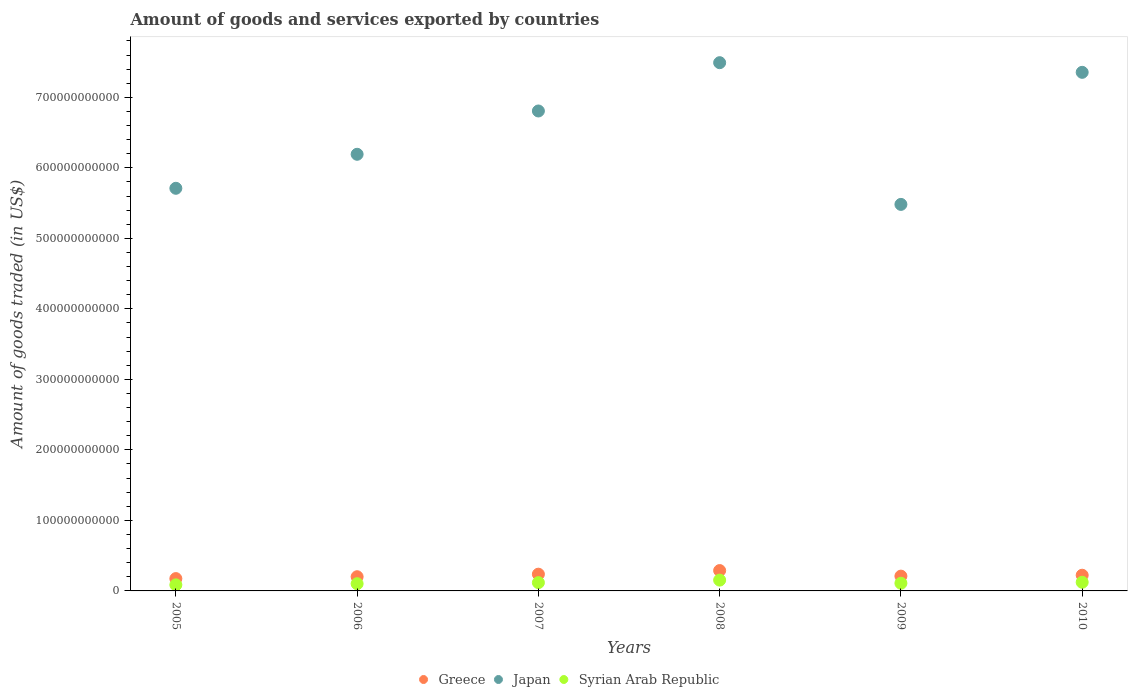How many different coloured dotlines are there?
Make the answer very short. 3. What is the total amount of goods and services exported in Greece in 2005?
Your answer should be very brief. 1.75e+1. Across all years, what is the maximum total amount of goods and services exported in Greece?
Provide a succinct answer. 2.89e+1. Across all years, what is the minimum total amount of goods and services exported in Japan?
Your response must be concise. 5.48e+11. In which year was the total amount of goods and services exported in Greece minimum?
Provide a succinct answer. 2005. What is the total total amount of goods and services exported in Greece in the graph?
Give a very brief answer. 1.33e+11. What is the difference between the total amount of goods and services exported in Japan in 2007 and that in 2009?
Ensure brevity in your answer.  1.32e+11. What is the difference between the total amount of goods and services exported in Syrian Arab Republic in 2005 and the total amount of goods and services exported in Japan in 2008?
Give a very brief answer. -7.41e+11. What is the average total amount of goods and services exported in Syrian Arab Republic per year?
Keep it short and to the point. 1.15e+1. In the year 2009, what is the difference between the total amount of goods and services exported in Syrian Arab Republic and total amount of goods and services exported in Greece?
Provide a short and direct response. -1.01e+1. What is the ratio of the total amount of goods and services exported in Japan in 2005 to that in 2007?
Ensure brevity in your answer.  0.84. Is the difference between the total amount of goods and services exported in Syrian Arab Republic in 2005 and 2008 greater than the difference between the total amount of goods and services exported in Greece in 2005 and 2008?
Provide a short and direct response. Yes. What is the difference between the highest and the second highest total amount of goods and services exported in Japan?
Your answer should be compact. 1.37e+1. What is the difference between the highest and the lowest total amount of goods and services exported in Syrian Arab Republic?
Keep it short and to the point. 6.73e+09. Does the total amount of goods and services exported in Syrian Arab Republic monotonically increase over the years?
Your response must be concise. No. Is the total amount of goods and services exported in Japan strictly greater than the total amount of goods and services exported in Syrian Arab Republic over the years?
Provide a succinct answer. Yes. Is the total amount of goods and services exported in Greece strictly less than the total amount of goods and services exported in Syrian Arab Republic over the years?
Provide a short and direct response. No. How many dotlines are there?
Provide a succinct answer. 3. What is the difference between two consecutive major ticks on the Y-axis?
Provide a short and direct response. 1.00e+11. Are the values on the major ticks of Y-axis written in scientific E-notation?
Your answer should be very brief. No. Where does the legend appear in the graph?
Keep it short and to the point. Bottom center. How many legend labels are there?
Your answer should be compact. 3. How are the legend labels stacked?
Provide a short and direct response. Horizontal. What is the title of the graph?
Offer a terse response. Amount of goods and services exported by countries. Does "Sint Maarten (Dutch part)" appear as one of the legend labels in the graph?
Provide a succinct answer. No. What is the label or title of the X-axis?
Provide a succinct answer. Years. What is the label or title of the Y-axis?
Your answer should be very brief. Amount of goods traded (in US$). What is the Amount of goods traded (in US$) of Greece in 2005?
Your answer should be compact. 1.75e+1. What is the Amount of goods traded (in US$) of Japan in 2005?
Offer a very short reply. 5.71e+11. What is the Amount of goods traded (in US$) of Syrian Arab Republic in 2005?
Provide a short and direct response. 8.60e+09. What is the Amount of goods traded (in US$) of Greece in 2006?
Your response must be concise. 2.01e+1. What is the Amount of goods traded (in US$) in Japan in 2006?
Keep it short and to the point. 6.19e+11. What is the Amount of goods traded (in US$) in Syrian Arab Republic in 2006?
Make the answer very short. 1.02e+1. What is the Amount of goods traded (in US$) in Greece in 2007?
Provide a succinct answer. 2.38e+1. What is the Amount of goods traded (in US$) in Japan in 2007?
Your answer should be very brief. 6.81e+11. What is the Amount of goods traded (in US$) in Syrian Arab Republic in 2007?
Your answer should be compact. 1.18e+1. What is the Amount of goods traded (in US$) in Greece in 2008?
Provide a short and direct response. 2.89e+1. What is the Amount of goods traded (in US$) of Japan in 2008?
Your answer should be very brief. 7.49e+11. What is the Amount of goods traded (in US$) of Syrian Arab Republic in 2008?
Provide a succinct answer. 1.53e+1. What is the Amount of goods traded (in US$) in Greece in 2009?
Offer a very short reply. 2.10e+1. What is the Amount of goods traded (in US$) in Japan in 2009?
Give a very brief answer. 5.48e+11. What is the Amount of goods traded (in US$) in Syrian Arab Republic in 2009?
Keep it short and to the point. 1.09e+1. What is the Amount of goods traded (in US$) of Greece in 2010?
Your answer should be very brief. 2.22e+1. What is the Amount of goods traded (in US$) of Japan in 2010?
Your answer should be compact. 7.35e+11. What is the Amount of goods traded (in US$) of Syrian Arab Republic in 2010?
Your answer should be compact. 1.23e+1. Across all years, what is the maximum Amount of goods traded (in US$) of Greece?
Your answer should be compact. 2.89e+1. Across all years, what is the maximum Amount of goods traded (in US$) of Japan?
Your answer should be very brief. 7.49e+11. Across all years, what is the maximum Amount of goods traded (in US$) in Syrian Arab Republic?
Ensure brevity in your answer.  1.53e+1. Across all years, what is the minimum Amount of goods traded (in US$) of Greece?
Make the answer very short. 1.75e+1. Across all years, what is the minimum Amount of goods traded (in US$) of Japan?
Ensure brevity in your answer.  5.48e+11. Across all years, what is the minimum Amount of goods traded (in US$) in Syrian Arab Republic?
Give a very brief answer. 8.60e+09. What is the total Amount of goods traded (in US$) of Greece in the graph?
Offer a very short reply. 1.33e+11. What is the total Amount of goods traded (in US$) in Japan in the graph?
Your answer should be very brief. 3.90e+12. What is the total Amount of goods traded (in US$) in Syrian Arab Republic in the graph?
Make the answer very short. 6.91e+1. What is the difference between the Amount of goods traded (in US$) in Greece in 2005 and that in 2006?
Offer a very short reply. -2.66e+09. What is the difference between the Amount of goods traded (in US$) of Japan in 2005 and that in 2006?
Your answer should be compact. -4.82e+1. What is the difference between the Amount of goods traded (in US$) in Syrian Arab Republic in 2005 and that in 2006?
Provide a short and direct response. -1.64e+09. What is the difference between the Amount of goods traded (in US$) in Greece in 2005 and that in 2007?
Offer a terse response. -6.28e+09. What is the difference between the Amount of goods traded (in US$) in Japan in 2005 and that in 2007?
Your answer should be very brief. -1.10e+11. What is the difference between the Amount of goods traded (in US$) of Syrian Arab Republic in 2005 and that in 2007?
Your answer should be very brief. -3.15e+09. What is the difference between the Amount of goods traded (in US$) of Greece in 2005 and that in 2008?
Provide a succinct answer. -1.14e+1. What is the difference between the Amount of goods traded (in US$) of Japan in 2005 and that in 2008?
Give a very brief answer. -1.78e+11. What is the difference between the Amount of goods traded (in US$) of Syrian Arab Republic in 2005 and that in 2008?
Your answer should be very brief. -6.73e+09. What is the difference between the Amount of goods traded (in US$) of Greece in 2005 and that in 2009?
Offer a terse response. -3.51e+09. What is the difference between the Amount of goods traded (in US$) of Japan in 2005 and that in 2009?
Make the answer very short. 2.28e+1. What is the difference between the Amount of goods traded (in US$) in Syrian Arab Republic in 2005 and that in 2009?
Offer a terse response. -2.28e+09. What is the difference between the Amount of goods traded (in US$) of Greece in 2005 and that in 2010?
Give a very brief answer. -4.78e+09. What is the difference between the Amount of goods traded (in US$) in Japan in 2005 and that in 2010?
Offer a very short reply. -1.64e+11. What is the difference between the Amount of goods traded (in US$) of Syrian Arab Republic in 2005 and that in 2010?
Make the answer very short. -3.67e+09. What is the difference between the Amount of goods traded (in US$) in Greece in 2006 and that in 2007?
Provide a short and direct response. -3.62e+09. What is the difference between the Amount of goods traded (in US$) in Japan in 2006 and that in 2007?
Make the answer very short. -6.14e+1. What is the difference between the Amount of goods traded (in US$) of Syrian Arab Republic in 2006 and that in 2007?
Your response must be concise. -1.51e+09. What is the difference between the Amount of goods traded (in US$) in Greece in 2006 and that in 2008?
Offer a terse response. -8.74e+09. What is the difference between the Amount of goods traded (in US$) in Japan in 2006 and that in 2008?
Ensure brevity in your answer.  -1.30e+11. What is the difference between the Amount of goods traded (in US$) in Syrian Arab Republic in 2006 and that in 2008?
Give a very brief answer. -5.09e+09. What is the difference between the Amount of goods traded (in US$) in Greece in 2006 and that in 2009?
Provide a short and direct response. -8.46e+08. What is the difference between the Amount of goods traded (in US$) of Japan in 2006 and that in 2009?
Your answer should be compact. 7.11e+1. What is the difference between the Amount of goods traded (in US$) of Syrian Arab Republic in 2006 and that in 2009?
Provide a short and direct response. -6.39e+08. What is the difference between the Amount of goods traded (in US$) in Greece in 2006 and that in 2010?
Your answer should be compact. -2.12e+09. What is the difference between the Amount of goods traded (in US$) in Japan in 2006 and that in 2010?
Your answer should be very brief. -1.16e+11. What is the difference between the Amount of goods traded (in US$) in Syrian Arab Republic in 2006 and that in 2010?
Provide a short and direct response. -2.03e+09. What is the difference between the Amount of goods traded (in US$) in Greece in 2007 and that in 2008?
Give a very brief answer. -5.11e+09. What is the difference between the Amount of goods traded (in US$) of Japan in 2007 and that in 2008?
Provide a short and direct response. -6.85e+1. What is the difference between the Amount of goods traded (in US$) in Syrian Arab Republic in 2007 and that in 2008?
Your response must be concise. -3.58e+09. What is the difference between the Amount of goods traded (in US$) in Greece in 2007 and that in 2009?
Give a very brief answer. 2.78e+09. What is the difference between the Amount of goods traded (in US$) of Japan in 2007 and that in 2009?
Offer a very short reply. 1.32e+11. What is the difference between the Amount of goods traded (in US$) of Syrian Arab Republic in 2007 and that in 2009?
Provide a short and direct response. 8.72e+08. What is the difference between the Amount of goods traded (in US$) in Greece in 2007 and that in 2010?
Your response must be concise. 1.50e+09. What is the difference between the Amount of goods traded (in US$) in Japan in 2007 and that in 2010?
Your answer should be very brief. -5.48e+1. What is the difference between the Amount of goods traded (in US$) in Syrian Arab Republic in 2007 and that in 2010?
Ensure brevity in your answer.  -5.17e+08. What is the difference between the Amount of goods traded (in US$) in Greece in 2008 and that in 2009?
Make the answer very short. 7.89e+09. What is the difference between the Amount of goods traded (in US$) in Japan in 2008 and that in 2009?
Your answer should be compact. 2.01e+11. What is the difference between the Amount of goods traded (in US$) of Syrian Arab Republic in 2008 and that in 2009?
Give a very brief answer. 4.45e+09. What is the difference between the Amount of goods traded (in US$) in Greece in 2008 and that in 2010?
Offer a terse response. 6.62e+09. What is the difference between the Amount of goods traded (in US$) in Japan in 2008 and that in 2010?
Ensure brevity in your answer.  1.37e+1. What is the difference between the Amount of goods traded (in US$) of Syrian Arab Republic in 2008 and that in 2010?
Provide a succinct answer. 3.06e+09. What is the difference between the Amount of goods traded (in US$) in Greece in 2009 and that in 2010?
Ensure brevity in your answer.  -1.27e+09. What is the difference between the Amount of goods traded (in US$) of Japan in 2009 and that in 2010?
Your answer should be compact. -1.87e+11. What is the difference between the Amount of goods traded (in US$) of Syrian Arab Republic in 2009 and that in 2010?
Ensure brevity in your answer.  -1.39e+09. What is the difference between the Amount of goods traded (in US$) of Greece in 2005 and the Amount of goods traded (in US$) of Japan in 2006?
Ensure brevity in your answer.  -6.02e+11. What is the difference between the Amount of goods traded (in US$) in Greece in 2005 and the Amount of goods traded (in US$) in Syrian Arab Republic in 2006?
Offer a terse response. 7.22e+09. What is the difference between the Amount of goods traded (in US$) of Japan in 2005 and the Amount of goods traded (in US$) of Syrian Arab Republic in 2006?
Your answer should be compact. 5.61e+11. What is the difference between the Amount of goods traded (in US$) of Greece in 2005 and the Amount of goods traded (in US$) of Japan in 2007?
Keep it short and to the point. -6.63e+11. What is the difference between the Amount of goods traded (in US$) in Greece in 2005 and the Amount of goods traded (in US$) in Syrian Arab Republic in 2007?
Give a very brief answer. 5.71e+09. What is the difference between the Amount of goods traded (in US$) in Japan in 2005 and the Amount of goods traded (in US$) in Syrian Arab Republic in 2007?
Offer a very short reply. 5.59e+11. What is the difference between the Amount of goods traded (in US$) in Greece in 2005 and the Amount of goods traded (in US$) in Japan in 2008?
Provide a short and direct response. -7.32e+11. What is the difference between the Amount of goods traded (in US$) of Greece in 2005 and the Amount of goods traded (in US$) of Syrian Arab Republic in 2008?
Your answer should be compact. 2.13e+09. What is the difference between the Amount of goods traded (in US$) of Japan in 2005 and the Amount of goods traded (in US$) of Syrian Arab Republic in 2008?
Offer a very short reply. 5.56e+11. What is the difference between the Amount of goods traded (in US$) in Greece in 2005 and the Amount of goods traded (in US$) in Japan in 2009?
Your response must be concise. -5.31e+11. What is the difference between the Amount of goods traded (in US$) of Greece in 2005 and the Amount of goods traded (in US$) of Syrian Arab Republic in 2009?
Ensure brevity in your answer.  6.59e+09. What is the difference between the Amount of goods traded (in US$) of Japan in 2005 and the Amount of goods traded (in US$) of Syrian Arab Republic in 2009?
Keep it short and to the point. 5.60e+11. What is the difference between the Amount of goods traded (in US$) of Greece in 2005 and the Amount of goods traded (in US$) of Japan in 2010?
Offer a terse response. -7.18e+11. What is the difference between the Amount of goods traded (in US$) of Greece in 2005 and the Amount of goods traded (in US$) of Syrian Arab Republic in 2010?
Your answer should be very brief. 5.20e+09. What is the difference between the Amount of goods traded (in US$) in Japan in 2005 and the Amount of goods traded (in US$) in Syrian Arab Republic in 2010?
Ensure brevity in your answer.  5.59e+11. What is the difference between the Amount of goods traded (in US$) of Greece in 2006 and the Amount of goods traded (in US$) of Japan in 2007?
Ensure brevity in your answer.  -6.60e+11. What is the difference between the Amount of goods traded (in US$) of Greece in 2006 and the Amount of goods traded (in US$) of Syrian Arab Republic in 2007?
Offer a very short reply. 8.37e+09. What is the difference between the Amount of goods traded (in US$) of Japan in 2006 and the Amount of goods traded (in US$) of Syrian Arab Republic in 2007?
Your response must be concise. 6.07e+11. What is the difference between the Amount of goods traded (in US$) of Greece in 2006 and the Amount of goods traded (in US$) of Japan in 2008?
Give a very brief answer. -7.29e+11. What is the difference between the Amount of goods traded (in US$) of Greece in 2006 and the Amount of goods traded (in US$) of Syrian Arab Republic in 2008?
Ensure brevity in your answer.  4.80e+09. What is the difference between the Amount of goods traded (in US$) in Japan in 2006 and the Amount of goods traded (in US$) in Syrian Arab Republic in 2008?
Your answer should be very brief. 6.04e+11. What is the difference between the Amount of goods traded (in US$) in Greece in 2006 and the Amount of goods traded (in US$) in Japan in 2009?
Provide a short and direct response. -5.28e+11. What is the difference between the Amount of goods traded (in US$) of Greece in 2006 and the Amount of goods traded (in US$) of Syrian Arab Republic in 2009?
Your answer should be very brief. 9.25e+09. What is the difference between the Amount of goods traded (in US$) in Japan in 2006 and the Amount of goods traded (in US$) in Syrian Arab Republic in 2009?
Your answer should be compact. 6.08e+11. What is the difference between the Amount of goods traded (in US$) in Greece in 2006 and the Amount of goods traded (in US$) in Japan in 2010?
Make the answer very short. -7.15e+11. What is the difference between the Amount of goods traded (in US$) of Greece in 2006 and the Amount of goods traded (in US$) of Syrian Arab Republic in 2010?
Offer a very short reply. 7.86e+09. What is the difference between the Amount of goods traded (in US$) in Japan in 2006 and the Amount of goods traded (in US$) in Syrian Arab Republic in 2010?
Your answer should be very brief. 6.07e+11. What is the difference between the Amount of goods traded (in US$) in Greece in 2007 and the Amount of goods traded (in US$) in Japan in 2008?
Your answer should be compact. -7.25e+11. What is the difference between the Amount of goods traded (in US$) of Greece in 2007 and the Amount of goods traded (in US$) of Syrian Arab Republic in 2008?
Your response must be concise. 8.42e+09. What is the difference between the Amount of goods traded (in US$) in Japan in 2007 and the Amount of goods traded (in US$) in Syrian Arab Republic in 2008?
Offer a terse response. 6.65e+11. What is the difference between the Amount of goods traded (in US$) in Greece in 2007 and the Amount of goods traded (in US$) in Japan in 2009?
Keep it short and to the point. -5.24e+11. What is the difference between the Amount of goods traded (in US$) of Greece in 2007 and the Amount of goods traded (in US$) of Syrian Arab Republic in 2009?
Your response must be concise. 1.29e+1. What is the difference between the Amount of goods traded (in US$) of Japan in 2007 and the Amount of goods traded (in US$) of Syrian Arab Republic in 2009?
Make the answer very short. 6.70e+11. What is the difference between the Amount of goods traded (in US$) in Greece in 2007 and the Amount of goods traded (in US$) in Japan in 2010?
Give a very brief answer. -7.12e+11. What is the difference between the Amount of goods traded (in US$) of Greece in 2007 and the Amount of goods traded (in US$) of Syrian Arab Republic in 2010?
Make the answer very short. 1.15e+1. What is the difference between the Amount of goods traded (in US$) in Japan in 2007 and the Amount of goods traded (in US$) in Syrian Arab Republic in 2010?
Your answer should be very brief. 6.68e+11. What is the difference between the Amount of goods traded (in US$) in Greece in 2008 and the Amount of goods traded (in US$) in Japan in 2009?
Offer a terse response. -5.19e+11. What is the difference between the Amount of goods traded (in US$) in Greece in 2008 and the Amount of goods traded (in US$) in Syrian Arab Republic in 2009?
Offer a terse response. 1.80e+1. What is the difference between the Amount of goods traded (in US$) of Japan in 2008 and the Amount of goods traded (in US$) of Syrian Arab Republic in 2009?
Your response must be concise. 7.38e+11. What is the difference between the Amount of goods traded (in US$) in Greece in 2008 and the Amount of goods traded (in US$) in Japan in 2010?
Provide a short and direct response. -7.07e+11. What is the difference between the Amount of goods traded (in US$) in Greece in 2008 and the Amount of goods traded (in US$) in Syrian Arab Republic in 2010?
Your answer should be compact. 1.66e+1. What is the difference between the Amount of goods traded (in US$) of Japan in 2008 and the Amount of goods traded (in US$) of Syrian Arab Republic in 2010?
Provide a succinct answer. 7.37e+11. What is the difference between the Amount of goods traded (in US$) of Greece in 2009 and the Amount of goods traded (in US$) of Japan in 2010?
Your answer should be very brief. -7.14e+11. What is the difference between the Amount of goods traded (in US$) of Greece in 2009 and the Amount of goods traded (in US$) of Syrian Arab Republic in 2010?
Provide a succinct answer. 8.70e+09. What is the difference between the Amount of goods traded (in US$) of Japan in 2009 and the Amount of goods traded (in US$) of Syrian Arab Republic in 2010?
Offer a terse response. 5.36e+11. What is the average Amount of goods traded (in US$) of Greece per year?
Offer a terse response. 2.22e+1. What is the average Amount of goods traded (in US$) of Japan per year?
Provide a short and direct response. 6.51e+11. What is the average Amount of goods traded (in US$) in Syrian Arab Republic per year?
Keep it short and to the point. 1.15e+1. In the year 2005, what is the difference between the Amount of goods traded (in US$) of Greece and Amount of goods traded (in US$) of Japan?
Your answer should be very brief. -5.54e+11. In the year 2005, what is the difference between the Amount of goods traded (in US$) in Greece and Amount of goods traded (in US$) in Syrian Arab Republic?
Keep it short and to the point. 8.87e+09. In the year 2005, what is the difference between the Amount of goods traded (in US$) of Japan and Amount of goods traded (in US$) of Syrian Arab Republic?
Make the answer very short. 5.62e+11. In the year 2006, what is the difference between the Amount of goods traded (in US$) in Greece and Amount of goods traded (in US$) in Japan?
Offer a terse response. -5.99e+11. In the year 2006, what is the difference between the Amount of goods traded (in US$) of Greece and Amount of goods traded (in US$) of Syrian Arab Republic?
Make the answer very short. 9.89e+09. In the year 2006, what is the difference between the Amount of goods traded (in US$) in Japan and Amount of goods traded (in US$) in Syrian Arab Republic?
Your response must be concise. 6.09e+11. In the year 2007, what is the difference between the Amount of goods traded (in US$) in Greece and Amount of goods traded (in US$) in Japan?
Your answer should be very brief. -6.57e+11. In the year 2007, what is the difference between the Amount of goods traded (in US$) in Greece and Amount of goods traded (in US$) in Syrian Arab Republic?
Ensure brevity in your answer.  1.20e+1. In the year 2007, what is the difference between the Amount of goods traded (in US$) in Japan and Amount of goods traded (in US$) in Syrian Arab Republic?
Ensure brevity in your answer.  6.69e+11. In the year 2008, what is the difference between the Amount of goods traded (in US$) of Greece and Amount of goods traded (in US$) of Japan?
Offer a terse response. -7.20e+11. In the year 2008, what is the difference between the Amount of goods traded (in US$) in Greece and Amount of goods traded (in US$) in Syrian Arab Republic?
Offer a terse response. 1.35e+1. In the year 2008, what is the difference between the Amount of goods traded (in US$) in Japan and Amount of goods traded (in US$) in Syrian Arab Republic?
Offer a very short reply. 7.34e+11. In the year 2009, what is the difference between the Amount of goods traded (in US$) in Greece and Amount of goods traded (in US$) in Japan?
Offer a very short reply. -5.27e+11. In the year 2009, what is the difference between the Amount of goods traded (in US$) in Greece and Amount of goods traded (in US$) in Syrian Arab Republic?
Your answer should be very brief. 1.01e+1. In the year 2009, what is the difference between the Amount of goods traded (in US$) in Japan and Amount of goods traded (in US$) in Syrian Arab Republic?
Ensure brevity in your answer.  5.37e+11. In the year 2010, what is the difference between the Amount of goods traded (in US$) in Greece and Amount of goods traded (in US$) in Japan?
Offer a terse response. -7.13e+11. In the year 2010, what is the difference between the Amount of goods traded (in US$) of Greece and Amount of goods traded (in US$) of Syrian Arab Republic?
Your answer should be very brief. 9.98e+09. In the year 2010, what is the difference between the Amount of goods traded (in US$) in Japan and Amount of goods traded (in US$) in Syrian Arab Republic?
Keep it short and to the point. 7.23e+11. What is the ratio of the Amount of goods traded (in US$) of Greece in 2005 to that in 2006?
Provide a short and direct response. 0.87. What is the ratio of the Amount of goods traded (in US$) in Japan in 2005 to that in 2006?
Your response must be concise. 0.92. What is the ratio of the Amount of goods traded (in US$) of Syrian Arab Republic in 2005 to that in 2006?
Offer a very short reply. 0.84. What is the ratio of the Amount of goods traded (in US$) of Greece in 2005 to that in 2007?
Keep it short and to the point. 0.74. What is the ratio of the Amount of goods traded (in US$) in Japan in 2005 to that in 2007?
Keep it short and to the point. 0.84. What is the ratio of the Amount of goods traded (in US$) in Syrian Arab Republic in 2005 to that in 2007?
Make the answer very short. 0.73. What is the ratio of the Amount of goods traded (in US$) in Greece in 2005 to that in 2008?
Your answer should be compact. 0.61. What is the ratio of the Amount of goods traded (in US$) in Japan in 2005 to that in 2008?
Make the answer very short. 0.76. What is the ratio of the Amount of goods traded (in US$) of Syrian Arab Republic in 2005 to that in 2008?
Provide a short and direct response. 0.56. What is the ratio of the Amount of goods traded (in US$) of Greece in 2005 to that in 2009?
Provide a short and direct response. 0.83. What is the ratio of the Amount of goods traded (in US$) in Japan in 2005 to that in 2009?
Your response must be concise. 1.04. What is the ratio of the Amount of goods traded (in US$) of Syrian Arab Republic in 2005 to that in 2009?
Offer a terse response. 0.79. What is the ratio of the Amount of goods traded (in US$) of Greece in 2005 to that in 2010?
Provide a succinct answer. 0.79. What is the ratio of the Amount of goods traded (in US$) of Japan in 2005 to that in 2010?
Make the answer very short. 0.78. What is the ratio of the Amount of goods traded (in US$) of Syrian Arab Republic in 2005 to that in 2010?
Provide a succinct answer. 0.7. What is the ratio of the Amount of goods traded (in US$) in Greece in 2006 to that in 2007?
Make the answer very short. 0.85. What is the ratio of the Amount of goods traded (in US$) in Japan in 2006 to that in 2007?
Ensure brevity in your answer.  0.91. What is the ratio of the Amount of goods traded (in US$) in Syrian Arab Republic in 2006 to that in 2007?
Offer a very short reply. 0.87. What is the ratio of the Amount of goods traded (in US$) of Greece in 2006 to that in 2008?
Provide a short and direct response. 0.7. What is the ratio of the Amount of goods traded (in US$) of Japan in 2006 to that in 2008?
Your answer should be compact. 0.83. What is the ratio of the Amount of goods traded (in US$) of Syrian Arab Republic in 2006 to that in 2008?
Your answer should be compact. 0.67. What is the ratio of the Amount of goods traded (in US$) in Greece in 2006 to that in 2009?
Ensure brevity in your answer.  0.96. What is the ratio of the Amount of goods traded (in US$) of Japan in 2006 to that in 2009?
Your answer should be very brief. 1.13. What is the ratio of the Amount of goods traded (in US$) of Syrian Arab Republic in 2006 to that in 2009?
Provide a short and direct response. 0.94. What is the ratio of the Amount of goods traded (in US$) of Greece in 2006 to that in 2010?
Make the answer very short. 0.9. What is the ratio of the Amount of goods traded (in US$) in Japan in 2006 to that in 2010?
Offer a terse response. 0.84. What is the ratio of the Amount of goods traded (in US$) of Syrian Arab Republic in 2006 to that in 2010?
Your answer should be compact. 0.83. What is the ratio of the Amount of goods traded (in US$) in Greece in 2007 to that in 2008?
Make the answer very short. 0.82. What is the ratio of the Amount of goods traded (in US$) of Japan in 2007 to that in 2008?
Give a very brief answer. 0.91. What is the ratio of the Amount of goods traded (in US$) of Syrian Arab Republic in 2007 to that in 2008?
Ensure brevity in your answer.  0.77. What is the ratio of the Amount of goods traded (in US$) of Greece in 2007 to that in 2009?
Provide a succinct answer. 1.13. What is the ratio of the Amount of goods traded (in US$) of Japan in 2007 to that in 2009?
Your response must be concise. 1.24. What is the ratio of the Amount of goods traded (in US$) of Syrian Arab Republic in 2007 to that in 2009?
Your response must be concise. 1.08. What is the ratio of the Amount of goods traded (in US$) of Greece in 2007 to that in 2010?
Offer a very short reply. 1.07. What is the ratio of the Amount of goods traded (in US$) in Japan in 2007 to that in 2010?
Provide a short and direct response. 0.93. What is the ratio of the Amount of goods traded (in US$) of Syrian Arab Republic in 2007 to that in 2010?
Offer a terse response. 0.96. What is the ratio of the Amount of goods traded (in US$) in Greece in 2008 to that in 2009?
Offer a very short reply. 1.38. What is the ratio of the Amount of goods traded (in US$) in Japan in 2008 to that in 2009?
Your answer should be very brief. 1.37. What is the ratio of the Amount of goods traded (in US$) in Syrian Arab Republic in 2008 to that in 2009?
Provide a succinct answer. 1.41. What is the ratio of the Amount of goods traded (in US$) of Greece in 2008 to that in 2010?
Ensure brevity in your answer.  1.3. What is the ratio of the Amount of goods traded (in US$) of Japan in 2008 to that in 2010?
Your answer should be compact. 1.02. What is the ratio of the Amount of goods traded (in US$) in Syrian Arab Republic in 2008 to that in 2010?
Make the answer very short. 1.25. What is the ratio of the Amount of goods traded (in US$) of Greece in 2009 to that in 2010?
Provide a short and direct response. 0.94. What is the ratio of the Amount of goods traded (in US$) of Japan in 2009 to that in 2010?
Ensure brevity in your answer.  0.75. What is the ratio of the Amount of goods traded (in US$) of Syrian Arab Republic in 2009 to that in 2010?
Provide a succinct answer. 0.89. What is the difference between the highest and the second highest Amount of goods traded (in US$) of Greece?
Ensure brevity in your answer.  5.11e+09. What is the difference between the highest and the second highest Amount of goods traded (in US$) of Japan?
Your answer should be compact. 1.37e+1. What is the difference between the highest and the second highest Amount of goods traded (in US$) in Syrian Arab Republic?
Keep it short and to the point. 3.06e+09. What is the difference between the highest and the lowest Amount of goods traded (in US$) of Greece?
Your answer should be compact. 1.14e+1. What is the difference between the highest and the lowest Amount of goods traded (in US$) of Japan?
Offer a terse response. 2.01e+11. What is the difference between the highest and the lowest Amount of goods traded (in US$) in Syrian Arab Republic?
Give a very brief answer. 6.73e+09. 